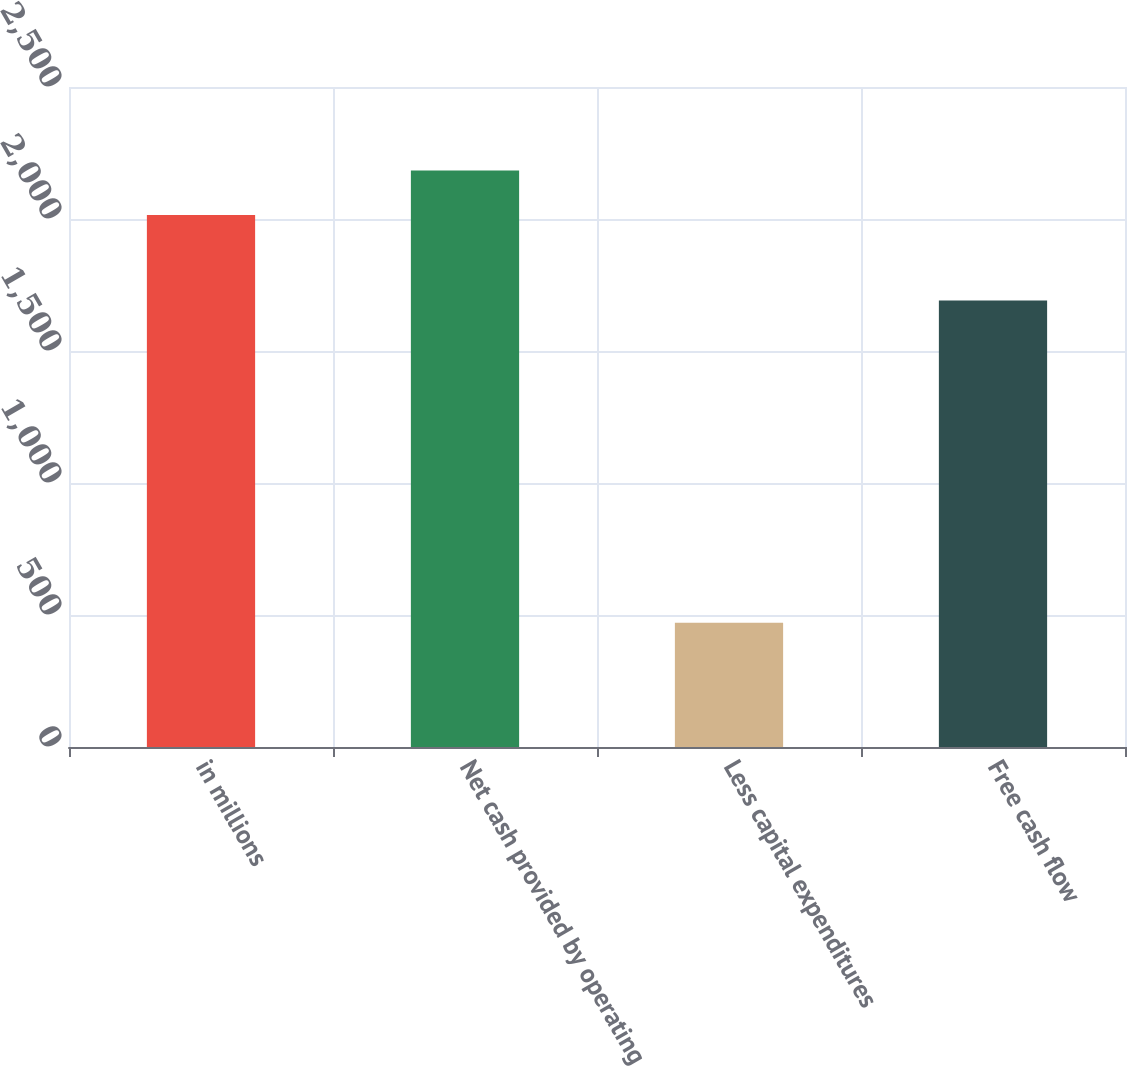Convert chart. <chart><loc_0><loc_0><loc_500><loc_500><bar_chart><fcel>in millions<fcel>Net cash provided by operating<fcel>Less capital expenditures<fcel>Free cash flow<nl><fcel>2015<fcel>2184.1<fcel>471<fcel>1691<nl></chart> 